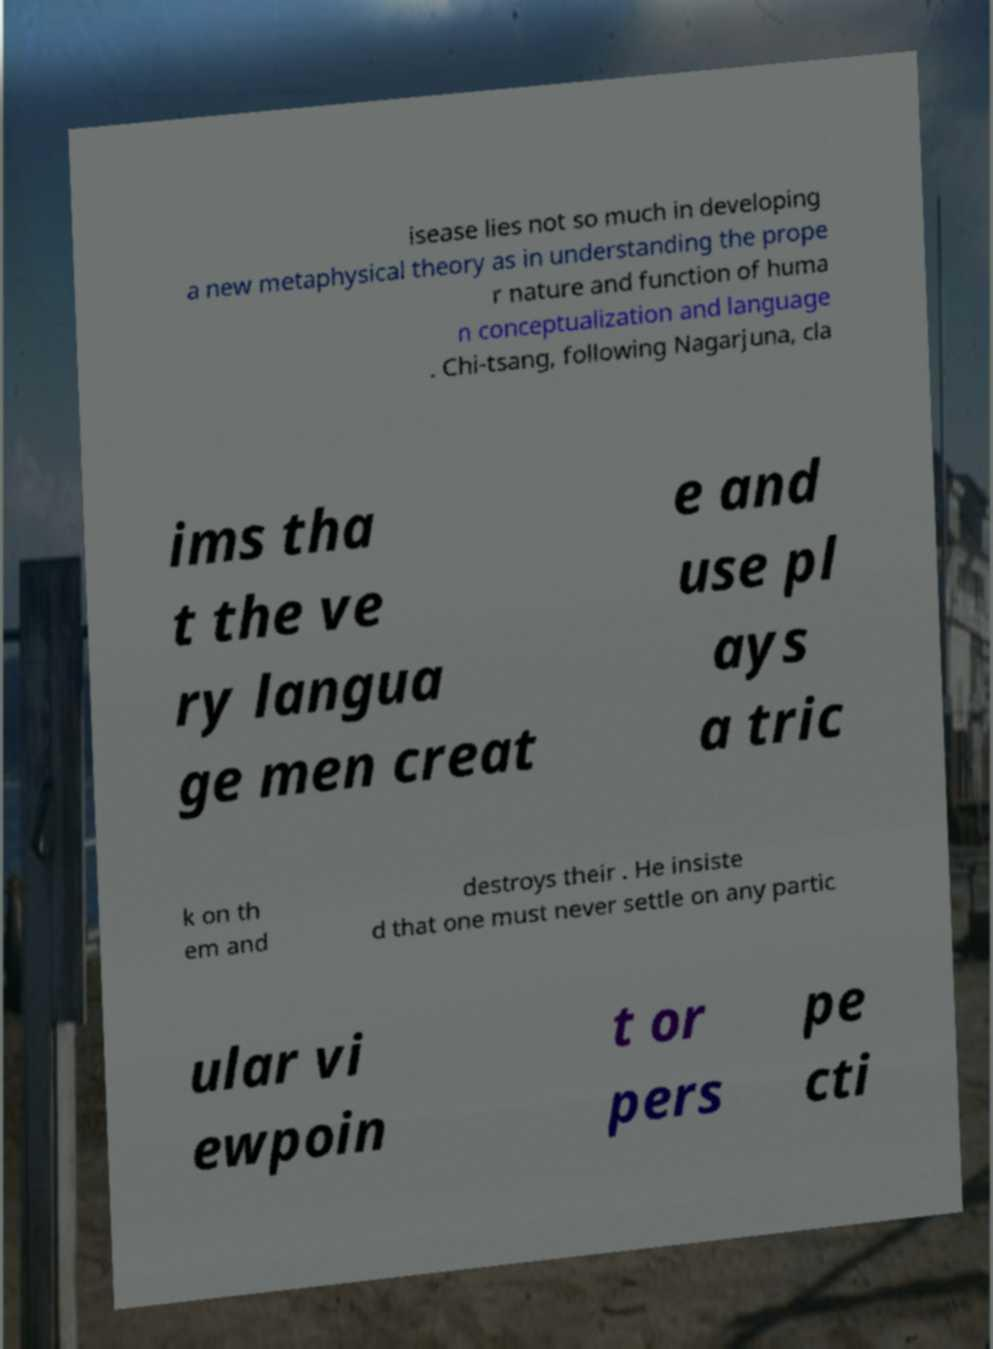Could you assist in decoding the text presented in this image and type it out clearly? isease lies not so much in developing a new metaphysical theory as in understanding the prope r nature and function of huma n conceptualization and language . Chi-tsang, following Nagarjuna, cla ims tha t the ve ry langua ge men creat e and use pl ays a tric k on th em and destroys their . He insiste d that one must never settle on any partic ular vi ewpoin t or pers pe cti 